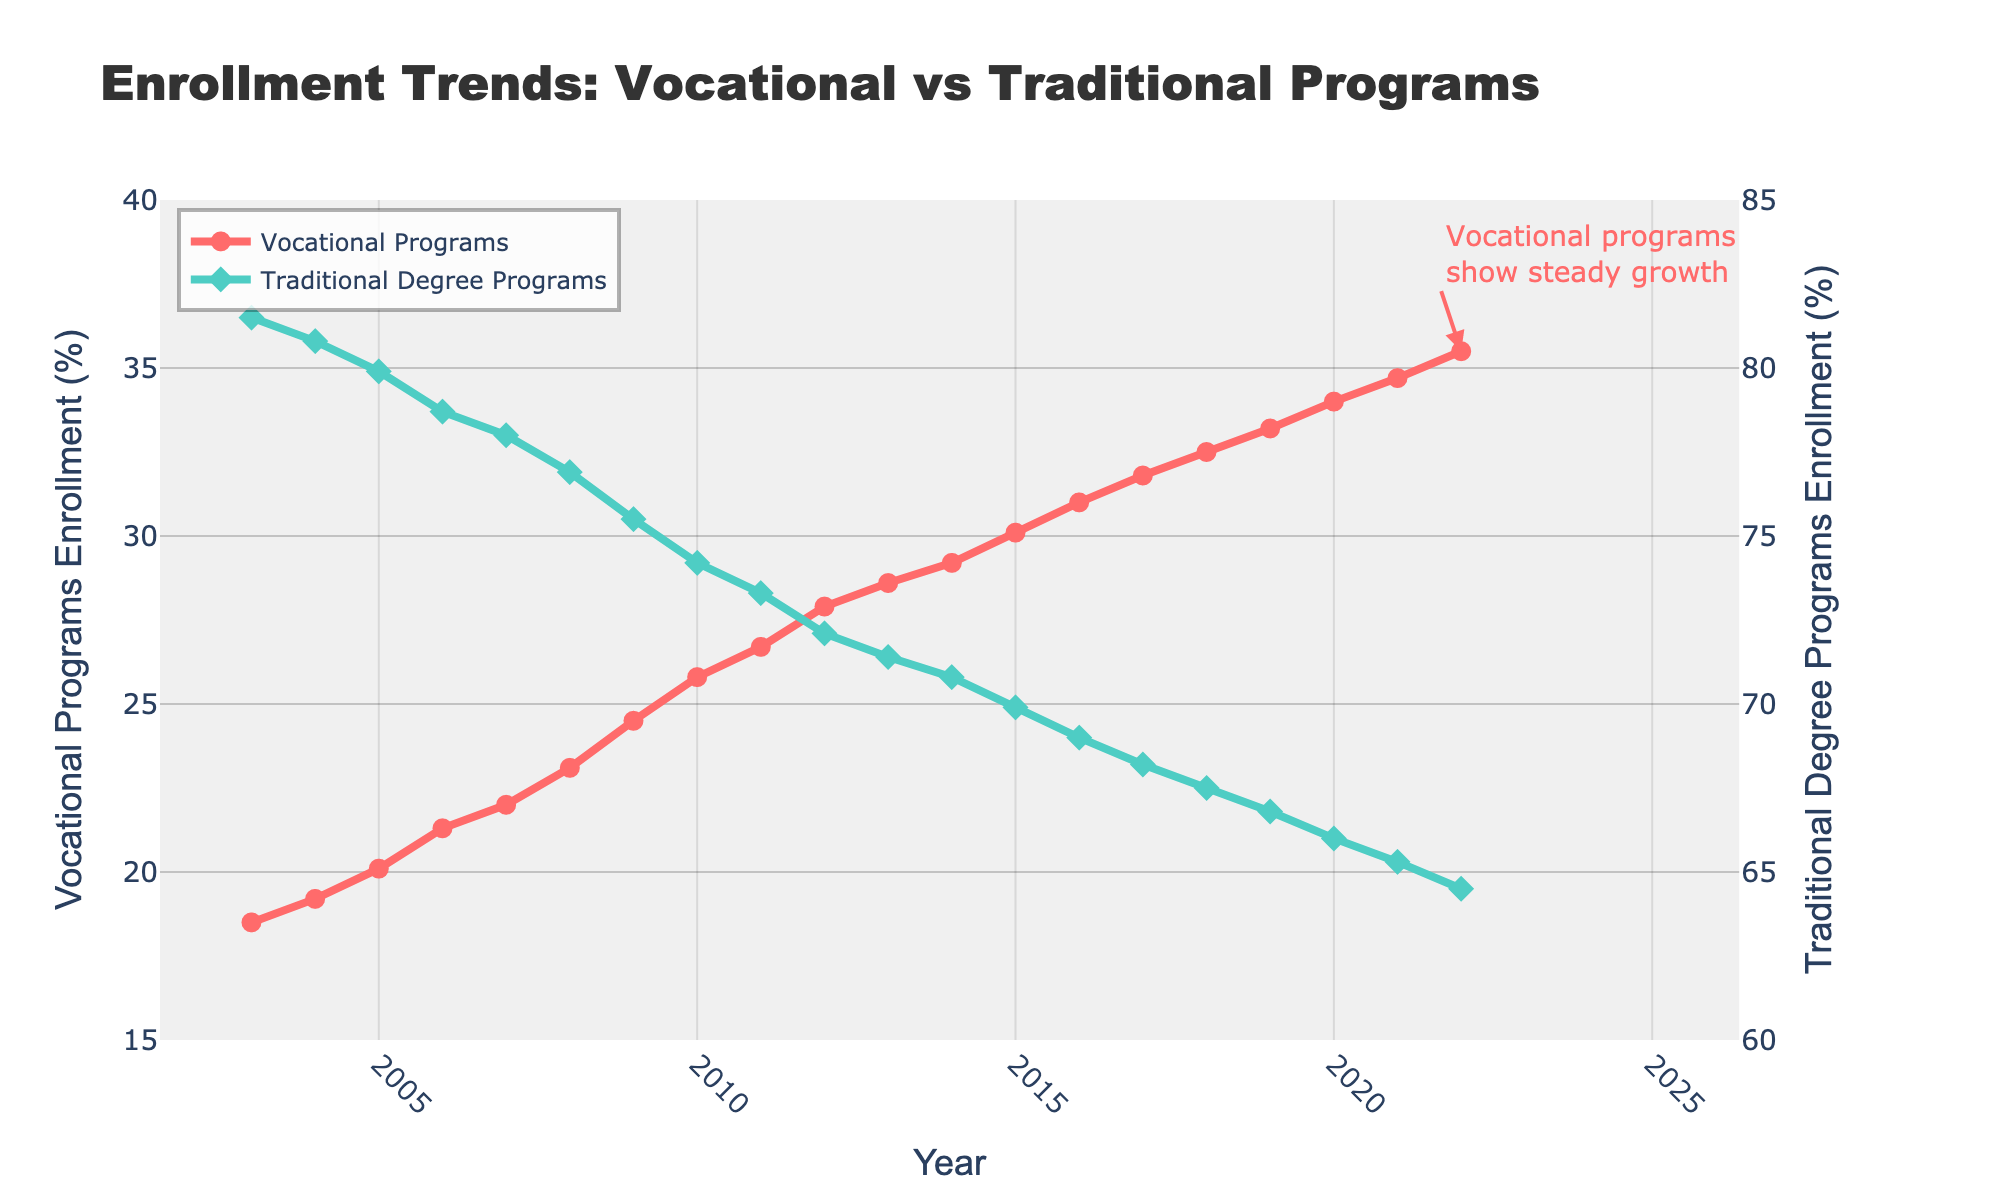How much did the enrollment in vocational programs increase between 2003 and 2022? To find the increase, subtract the 2003 enrollment percentage (18.5%) from the 2022 enrollment percentage (35.5%). So, 35.5 - 18.5 = 17.
Answer: 17 In which year did vocational program enrollments exceed 30%? Look at the trend line for vocational programs and identify the year where the enrollment percentage exceeded 30%. It first happens in 2015 (30.1%).
Answer: 2015 Which type of program had a higher enrollment percentage in 2010? Compare the values for both vocational (25.8%) and traditional degree (74.2%) programs in 2010. Traditional degree programs had a higher percentage.
Answer: Traditional degree programs By how much did the enrollment in traditional degree programs decrease from 2009 to 2022? To find the decrease, subtract the 2022 enrollment percentage (64.5%) from the 2009 enrollment percentage (75.5%). So, 75.5 - 64.5 = 11.
Answer: 11 Which enrollment trend is visually represented by a red line on the plot? The red line represents vocational programs, as indicated in the legend.
Answer: Vocational programs Between which two consecutive years did vocational programs see the largest enrollment increase? Calculate the year-over-year increase in vocational program enrollments across all years and identify the biggest jump. The increase is largest between 2009 (24.5%) and 2010 (25.8%), a rise of 1.3%.
Answer: 2009 and 2010 What is the enrollment percentage for traditional degree programs in 2018? Refer to the data point for traditional degree programs in 2018, which is 67.5%.
Answer: 67.5 On the plot, is the gap between vocational programs and traditional degree programs wider in 2003 or in 2022? Compare the differences: in 2003, the gap is 81.5 - 18.5 = 63; in 2022, it's 64.5 - 35.5 = 29. The gap is wider in 2003.
Answer: 2003 What trend can be observed for vocational program enrollments from 2003 to 2022? Examine the line for vocational programs over the years. The trend shows consistent growth.
Answer: Steady growth 